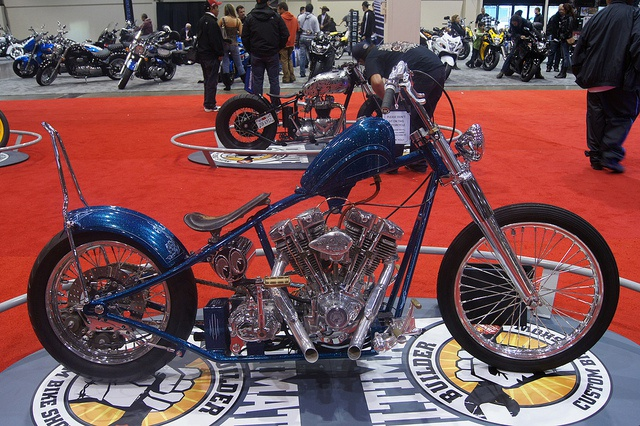Describe the objects in this image and their specific colors. I can see motorcycle in black, gray, navy, and maroon tones, motorcycle in black, gray, maroon, and red tones, people in black, red, and maroon tones, motorcycle in black, gray, darkgray, and lightgray tones, and people in black, darkgray, gray, and white tones in this image. 